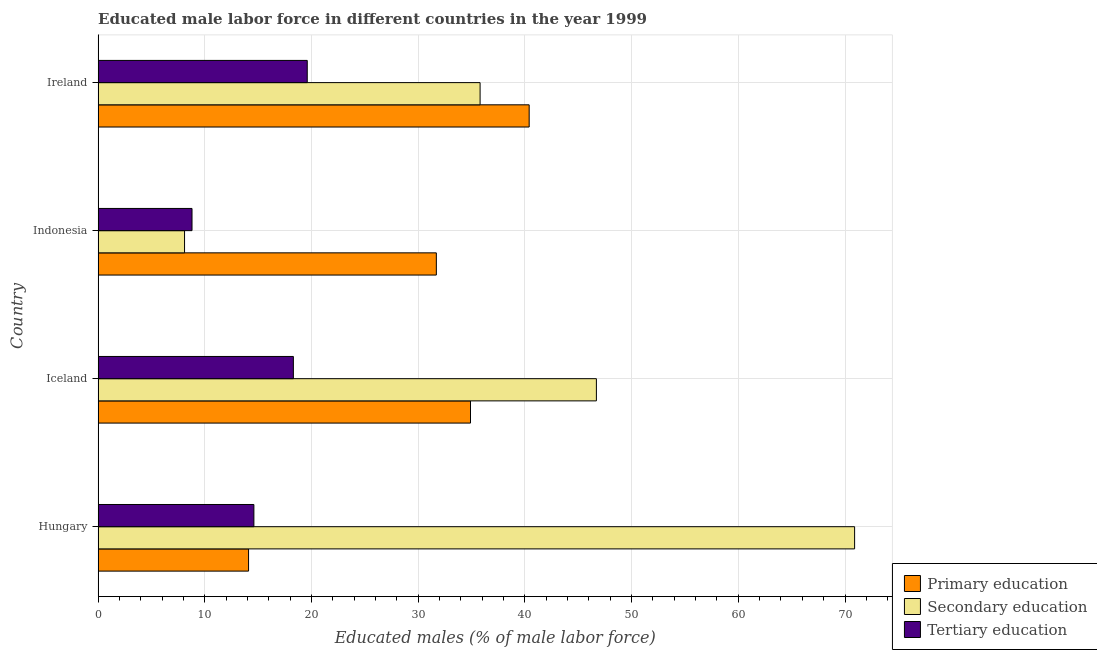How many different coloured bars are there?
Your response must be concise. 3. How many bars are there on the 2nd tick from the top?
Make the answer very short. 3. How many bars are there on the 4th tick from the bottom?
Keep it short and to the point. 3. What is the label of the 1st group of bars from the top?
Your response must be concise. Ireland. What is the percentage of male labor force who received secondary education in Indonesia?
Offer a very short reply. 8.1. Across all countries, what is the maximum percentage of male labor force who received secondary education?
Your answer should be compact. 70.9. Across all countries, what is the minimum percentage of male labor force who received primary education?
Your answer should be very brief. 14.1. In which country was the percentage of male labor force who received secondary education maximum?
Provide a succinct answer. Hungary. What is the total percentage of male labor force who received secondary education in the graph?
Keep it short and to the point. 161.5. What is the difference between the percentage of male labor force who received secondary education in Iceland and that in Indonesia?
Your response must be concise. 38.6. What is the difference between the percentage of male labor force who received primary education in Hungary and the percentage of male labor force who received secondary education in Ireland?
Provide a short and direct response. -21.7. What is the average percentage of male labor force who received secondary education per country?
Keep it short and to the point. 40.38. What is the ratio of the percentage of male labor force who received tertiary education in Iceland to that in Indonesia?
Keep it short and to the point. 2.08. Is the difference between the percentage of male labor force who received tertiary education in Hungary and Indonesia greater than the difference between the percentage of male labor force who received primary education in Hungary and Indonesia?
Offer a terse response. Yes. What is the difference between the highest and the second highest percentage of male labor force who received tertiary education?
Your answer should be very brief. 1.3. What is the difference between the highest and the lowest percentage of male labor force who received primary education?
Your response must be concise. 26.3. In how many countries, is the percentage of male labor force who received primary education greater than the average percentage of male labor force who received primary education taken over all countries?
Provide a succinct answer. 3. What does the 1st bar from the top in Hungary represents?
Your answer should be compact. Tertiary education. What does the 3rd bar from the bottom in Ireland represents?
Offer a very short reply. Tertiary education. Is it the case that in every country, the sum of the percentage of male labor force who received primary education and percentage of male labor force who received secondary education is greater than the percentage of male labor force who received tertiary education?
Offer a very short reply. Yes. How many bars are there?
Give a very brief answer. 12. Are all the bars in the graph horizontal?
Provide a succinct answer. Yes. How many countries are there in the graph?
Offer a very short reply. 4. Are the values on the major ticks of X-axis written in scientific E-notation?
Provide a short and direct response. No. Does the graph contain any zero values?
Your answer should be compact. No. Where does the legend appear in the graph?
Provide a short and direct response. Bottom right. How many legend labels are there?
Your response must be concise. 3. How are the legend labels stacked?
Ensure brevity in your answer.  Vertical. What is the title of the graph?
Provide a succinct answer. Educated male labor force in different countries in the year 1999. Does "Industrial Nitrous Oxide" appear as one of the legend labels in the graph?
Give a very brief answer. No. What is the label or title of the X-axis?
Offer a terse response. Educated males (% of male labor force). What is the Educated males (% of male labor force) in Primary education in Hungary?
Offer a terse response. 14.1. What is the Educated males (% of male labor force) in Secondary education in Hungary?
Offer a very short reply. 70.9. What is the Educated males (% of male labor force) of Tertiary education in Hungary?
Provide a short and direct response. 14.6. What is the Educated males (% of male labor force) of Primary education in Iceland?
Provide a short and direct response. 34.9. What is the Educated males (% of male labor force) in Secondary education in Iceland?
Offer a terse response. 46.7. What is the Educated males (% of male labor force) in Tertiary education in Iceland?
Give a very brief answer. 18.3. What is the Educated males (% of male labor force) of Primary education in Indonesia?
Make the answer very short. 31.7. What is the Educated males (% of male labor force) of Secondary education in Indonesia?
Give a very brief answer. 8.1. What is the Educated males (% of male labor force) in Tertiary education in Indonesia?
Provide a succinct answer. 8.8. What is the Educated males (% of male labor force) of Primary education in Ireland?
Offer a very short reply. 40.4. What is the Educated males (% of male labor force) in Secondary education in Ireland?
Provide a succinct answer. 35.8. What is the Educated males (% of male labor force) of Tertiary education in Ireland?
Ensure brevity in your answer.  19.6. Across all countries, what is the maximum Educated males (% of male labor force) in Primary education?
Make the answer very short. 40.4. Across all countries, what is the maximum Educated males (% of male labor force) in Secondary education?
Your answer should be very brief. 70.9. Across all countries, what is the maximum Educated males (% of male labor force) of Tertiary education?
Ensure brevity in your answer.  19.6. Across all countries, what is the minimum Educated males (% of male labor force) of Primary education?
Ensure brevity in your answer.  14.1. Across all countries, what is the minimum Educated males (% of male labor force) of Secondary education?
Offer a terse response. 8.1. Across all countries, what is the minimum Educated males (% of male labor force) in Tertiary education?
Provide a short and direct response. 8.8. What is the total Educated males (% of male labor force) of Primary education in the graph?
Your response must be concise. 121.1. What is the total Educated males (% of male labor force) of Secondary education in the graph?
Give a very brief answer. 161.5. What is the total Educated males (% of male labor force) of Tertiary education in the graph?
Provide a short and direct response. 61.3. What is the difference between the Educated males (% of male labor force) in Primary education in Hungary and that in Iceland?
Keep it short and to the point. -20.8. What is the difference between the Educated males (% of male labor force) of Secondary education in Hungary and that in Iceland?
Give a very brief answer. 24.2. What is the difference between the Educated males (% of male labor force) of Primary education in Hungary and that in Indonesia?
Keep it short and to the point. -17.6. What is the difference between the Educated males (% of male labor force) in Secondary education in Hungary and that in Indonesia?
Keep it short and to the point. 62.8. What is the difference between the Educated males (% of male labor force) of Tertiary education in Hungary and that in Indonesia?
Provide a succinct answer. 5.8. What is the difference between the Educated males (% of male labor force) of Primary education in Hungary and that in Ireland?
Offer a terse response. -26.3. What is the difference between the Educated males (% of male labor force) of Secondary education in Hungary and that in Ireland?
Your response must be concise. 35.1. What is the difference between the Educated males (% of male labor force) of Tertiary education in Hungary and that in Ireland?
Keep it short and to the point. -5. What is the difference between the Educated males (% of male labor force) of Primary education in Iceland and that in Indonesia?
Provide a short and direct response. 3.2. What is the difference between the Educated males (% of male labor force) of Secondary education in Iceland and that in Indonesia?
Make the answer very short. 38.6. What is the difference between the Educated males (% of male labor force) of Tertiary education in Iceland and that in Indonesia?
Keep it short and to the point. 9.5. What is the difference between the Educated males (% of male labor force) of Primary education in Iceland and that in Ireland?
Offer a very short reply. -5.5. What is the difference between the Educated males (% of male labor force) of Secondary education in Iceland and that in Ireland?
Your answer should be very brief. 10.9. What is the difference between the Educated males (% of male labor force) in Primary education in Indonesia and that in Ireland?
Provide a succinct answer. -8.7. What is the difference between the Educated males (% of male labor force) of Secondary education in Indonesia and that in Ireland?
Your response must be concise. -27.7. What is the difference between the Educated males (% of male labor force) of Tertiary education in Indonesia and that in Ireland?
Provide a succinct answer. -10.8. What is the difference between the Educated males (% of male labor force) in Primary education in Hungary and the Educated males (% of male labor force) in Secondary education in Iceland?
Make the answer very short. -32.6. What is the difference between the Educated males (% of male labor force) of Primary education in Hungary and the Educated males (% of male labor force) of Tertiary education in Iceland?
Offer a very short reply. -4.2. What is the difference between the Educated males (% of male labor force) of Secondary education in Hungary and the Educated males (% of male labor force) of Tertiary education in Iceland?
Make the answer very short. 52.6. What is the difference between the Educated males (% of male labor force) in Primary education in Hungary and the Educated males (% of male labor force) in Secondary education in Indonesia?
Give a very brief answer. 6. What is the difference between the Educated males (% of male labor force) in Secondary education in Hungary and the Educated males (% of male labor force) in Tertiary education in Indonesia?
Your answer should be compact. 62.1. What is the difference between the Educated males (% of male labor force) in Primary education in Hungary and the Educated males (% of male labor force) in Secondary education in Ireland?
Keep it short and to the point. -21.7. What is the difference between the Educated males (% of male labor force) in Primary education in Hungary and the Educated males (% of male labor force) in Tertiary education in Ireland?
Your response must be concise. -5.5. What is the difference between the Educated males (% of male labor force) in Secondary education in Hungary and the Educated males (% of male labor force) in Tertiary education in Ireland?
Ensure brevity in your answer.  51.3. What is the difference between the Educated males (% of male labor force) in Primary education in Iceland and the Educated males (% of male labor force) in Secondary education in Indonesia?
Your answer should be very brief. 26.8. What is the difference between the Educated males (% of male labor force) in Primary education in Iceland and the Educated males (% of male labor force) in Tertiary education in Indonesia?
Offer a very short reply. 26.1. What is the difference between the Educated males (% of male labor force) in Secondary education in Iceland and the Educated males (% of male labor force) in Tertiary education in Indonesia?
Keep it short and to the point. 37.9. What is the difference between the Educated males (% of male labor force) of Primary education in Iceland and the Educated males (% of male labor force) of Secondary education in Ireland?
Your answer should be compact. -0.9. What is the difference between the Educated males (% of male labor force) of Primary education in Iceland and the Educated males (% of male labor force) of Tertiary education in Ireland?
Offer a very short reply. 15.3. What is the difference between the Educated males (% of male labor force) of Secondary education in Iceland and the Educated males (% of male labor force) of Tertiary education in Ireland?
Offer a terse response. 27.1. What is the difference between the Educated males (% of male labor force) of Primary education in Indonesia and the Educated males (% of male labor force) of Secondary education in Ireland?
Your answer should be very brief. -4.1. What is the difference between the Educated males (% of male labor force) of Primary education in Indonesia and the Educated males (% of male labor force) of Tertiary education in Ireland?
Keep it short and to the point. 12.1. What is the average Educated males (% of male labor force) of Primary education per country?
Offer a very short reply. 30.27. What is the average Educated males (% of male labor force) of Secondary education per country?
Make the answer very short. 40.38. What is the average Educated males (% of male labor force) of Tertiary education per country?
Provide a succinct answer. 15.32. What is the difference between the Educated males (% of male labor force) of Primary education and Educated males (% of male labor force) of Secondary education in Hungary?
Your response must be concise. -56.8. What is the difference between the Educated males (% of male labor force) in Primary education and Educated males (% of male labor force) in Tertiary education in Hungary?
Your answer should be compact. -0.5. What is the difference between the Educated males (% of male labor force) of Secondary education and Educated males (% of male labor force) of Tertiary education in Hungary?
Your answer should be very brief. 56.3. What is the difference between the Educated males (% of male labor force) in Primary education and Educated males (% of male labor force) in Tertiary education in Iceland?
Offer a very short reply. 16.6. What is the difference between the Educated males (% of male labor force) in Secondary education and Educated males (% of male labor force) in Tertiary education in Iceland?
Your response must be concise. 28.4. What is the difference between the Educated males (% of male labor force) in Primary education and Educated males (% of male labor force) in Secondary education in Indonesia?
Make the answer very short. 23.6. What is the difference between the Educated males (% of male labor force) of Primary education and Educated males (% of male labor force) of Tertiary education in Indonesia?
Offer a terse response. 22.9. What is the difference between the Educated males (% of male labor force) of Secondary education and Educated males (% of male labor force) of Tertiary education in Indonesia?
Offer a very short reply. -0.7. What is the difference between the Educated males (% of male labor force) of Primary education and Educated males (% of male labor force) of Secondary education in Ireland?
Provide a short and direct response. 4.6. What is the difference between the Educated males (% of male labor force) of Primary education and Educated males (% of male labor force) of Tertiary education in Ireland?
Give a very brief answer. 20.8. What is the difference between the Educated males (% of male labor force) of Secondary education and Educated males (% of male labor force) of Tertiary education in Ireland?
Provide a short and direct response. 16.2. What is the ratio of the Educated males (% of male labor force) of Primary education in Hungary to that in Iceland?
Keep it short and to the point. 0.4. What is the ratio of the Educated males (% of male labor force) in Secondary education in Hungary to that in Iceland?
Keep it short and to the point. 1.52. What is the ratio of the Educated males (% of male labor force) of Tertiary education in Hungary to that in Iceland?
Ensure brevity in your answer.  0.8. What is the ratio of the Educated males (% of male labor force) of Primary education in Hungary to that in Indonesia?
Give a very brief answer. 0.44. What is the ratio of the Educated males (% of male labor force) of Secondary education in Hungary to that in Indonesia?
Provide a short and direct response. 8.75. What is the ratio of the Educated males (% of male labor force) of Tertiary education in Hungary to that in Indonesia?
Offer a terse response. 1.66. What is the ratio of the Educated males (% of male labor force) in Primary education in Hungary to that in Ireland?
Provide a short and direct response. 0.35. What is the ratio of the Educated males (% of male labor force) of Secondary education in Hungary to that in Ireland?
Offer a very short reply. 1.98. What is the ratio of the Educated males (% of male labor force) in Tertiary education in Hungary to that in Ireland?
Make the answer very short. 0.74. What is the ratio of the Educated males (% of male labor force) of Primary education in Iceland to that in Indonesia?
Your answer should be very brief. 1.1. What is the ratio of the Educated males (% of male labor force) in Secondary education in Iceland to that in Indonesia?
Ensure brevity in your answer.  5.77. What is the ratio of the Educated males (% of male labor force) in Tertiary education in Iceland to that in Indonesia?
Provide a succinct answer. 2.08. What is the ratio of the Educated males (% of male labor force) in Primary education in Iceland to that in Ireland?
Provide a succinct answer. 0.86. What is the ratio of the Educated males (% of male labor force) of Secondary education in Iceland to that in Ireland?
Offer a terse response. 1.3. What is the ratio of the Educated males (% of male labor force) in Tertiary education in Iceland to that in Ireland?
Make the answer very short. 0.93. What is the ratio of the Educated males (% of male labor force) of Primary education in Indonesia to that in Ireland?
Offer a very short reply. 0.78. What is the ratio of the Educated males (% of male labor force) in Secondary education in Indonesia to that in Ireland?
Your answer should be compact. 0.23. What is the ratio of the Educated males (% of male labor force) of Tertiary education in Indonesia to that in Ireland?
Your answer should be compact. 0.45. What is the difference between the highest and the second highest Educated males (% of male labor force) of Secondary education?
Keep it short and to the point. 24.2. What is the difference between the highest and the lowest Educated males (% of male labor force) in Primary education?
Ensure brevity in your answer.  26.3. What is the difference between the highest and the lowest Educated males (% of male labor force) in Secondary education?
Provide a succinct answer. 62.8. What is the difference between the highest and the lowest Educated males (% of male labor force) in Tertiary education?
Give a very brief answer. 10.8. 